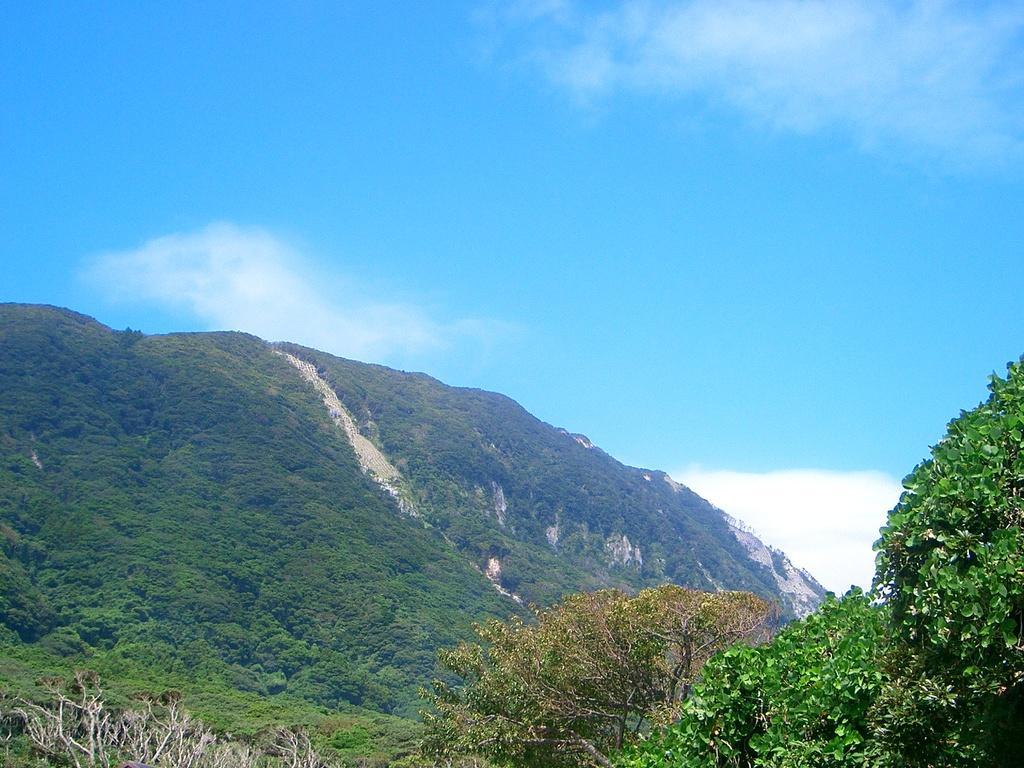Could you give a brief overview of what you see in this image? In this image we can see hills, trees, plants and we can also see the sky. 